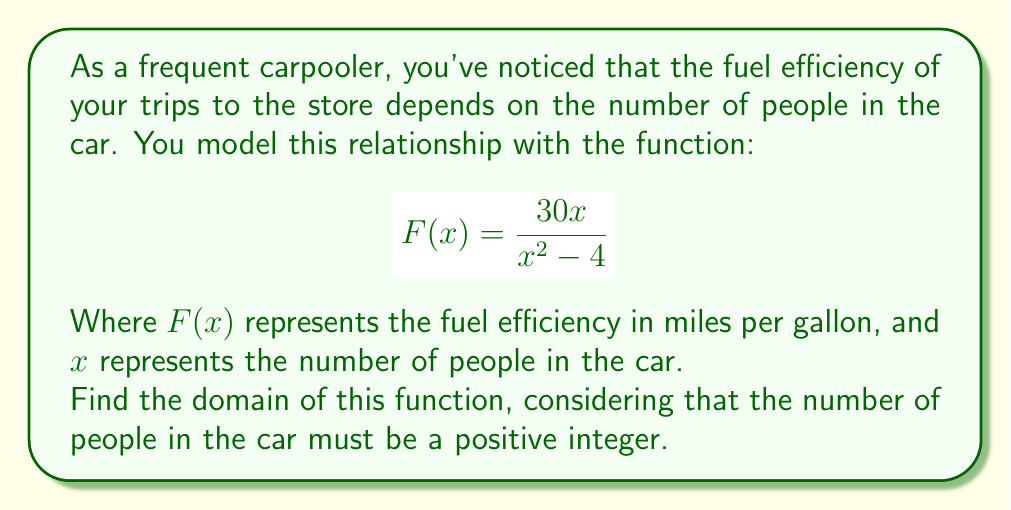Solve this math problem. Let's approach this step-by-step:

1) First, recall that the domain of a rational function includes all real numbers except those that make the denominator equal to zero.

2) Set the denominator equal to zero and solve:
   $$x^2 - 4 = 0$$
   $$(x+2)(x-2) = 0$$
   $$x = 2 \text{ or } x = -2$$

3) This means that $x$ cannot be 2 or -2, as these values would make the denominator zero, causing the function to be undefined.

4) However, we also need to consider the context of the problem. The number of people in a car:
   a) Must be a positive number (we can't have negative people)
   b) Must be an integer (we can't have fractional people)

5) Therefore, the domain consists of all positive integers, except 2.

6) We can express this in set notation as:
   $$\{x \in \mathbb{Z}^+ : x \neq 2\}$$

   Where $\mathbb{Z}^+$ represents the set of positive integers.
Answer: $\{x \in \mathbb{Z}^+ : x \neq 2\}$ 